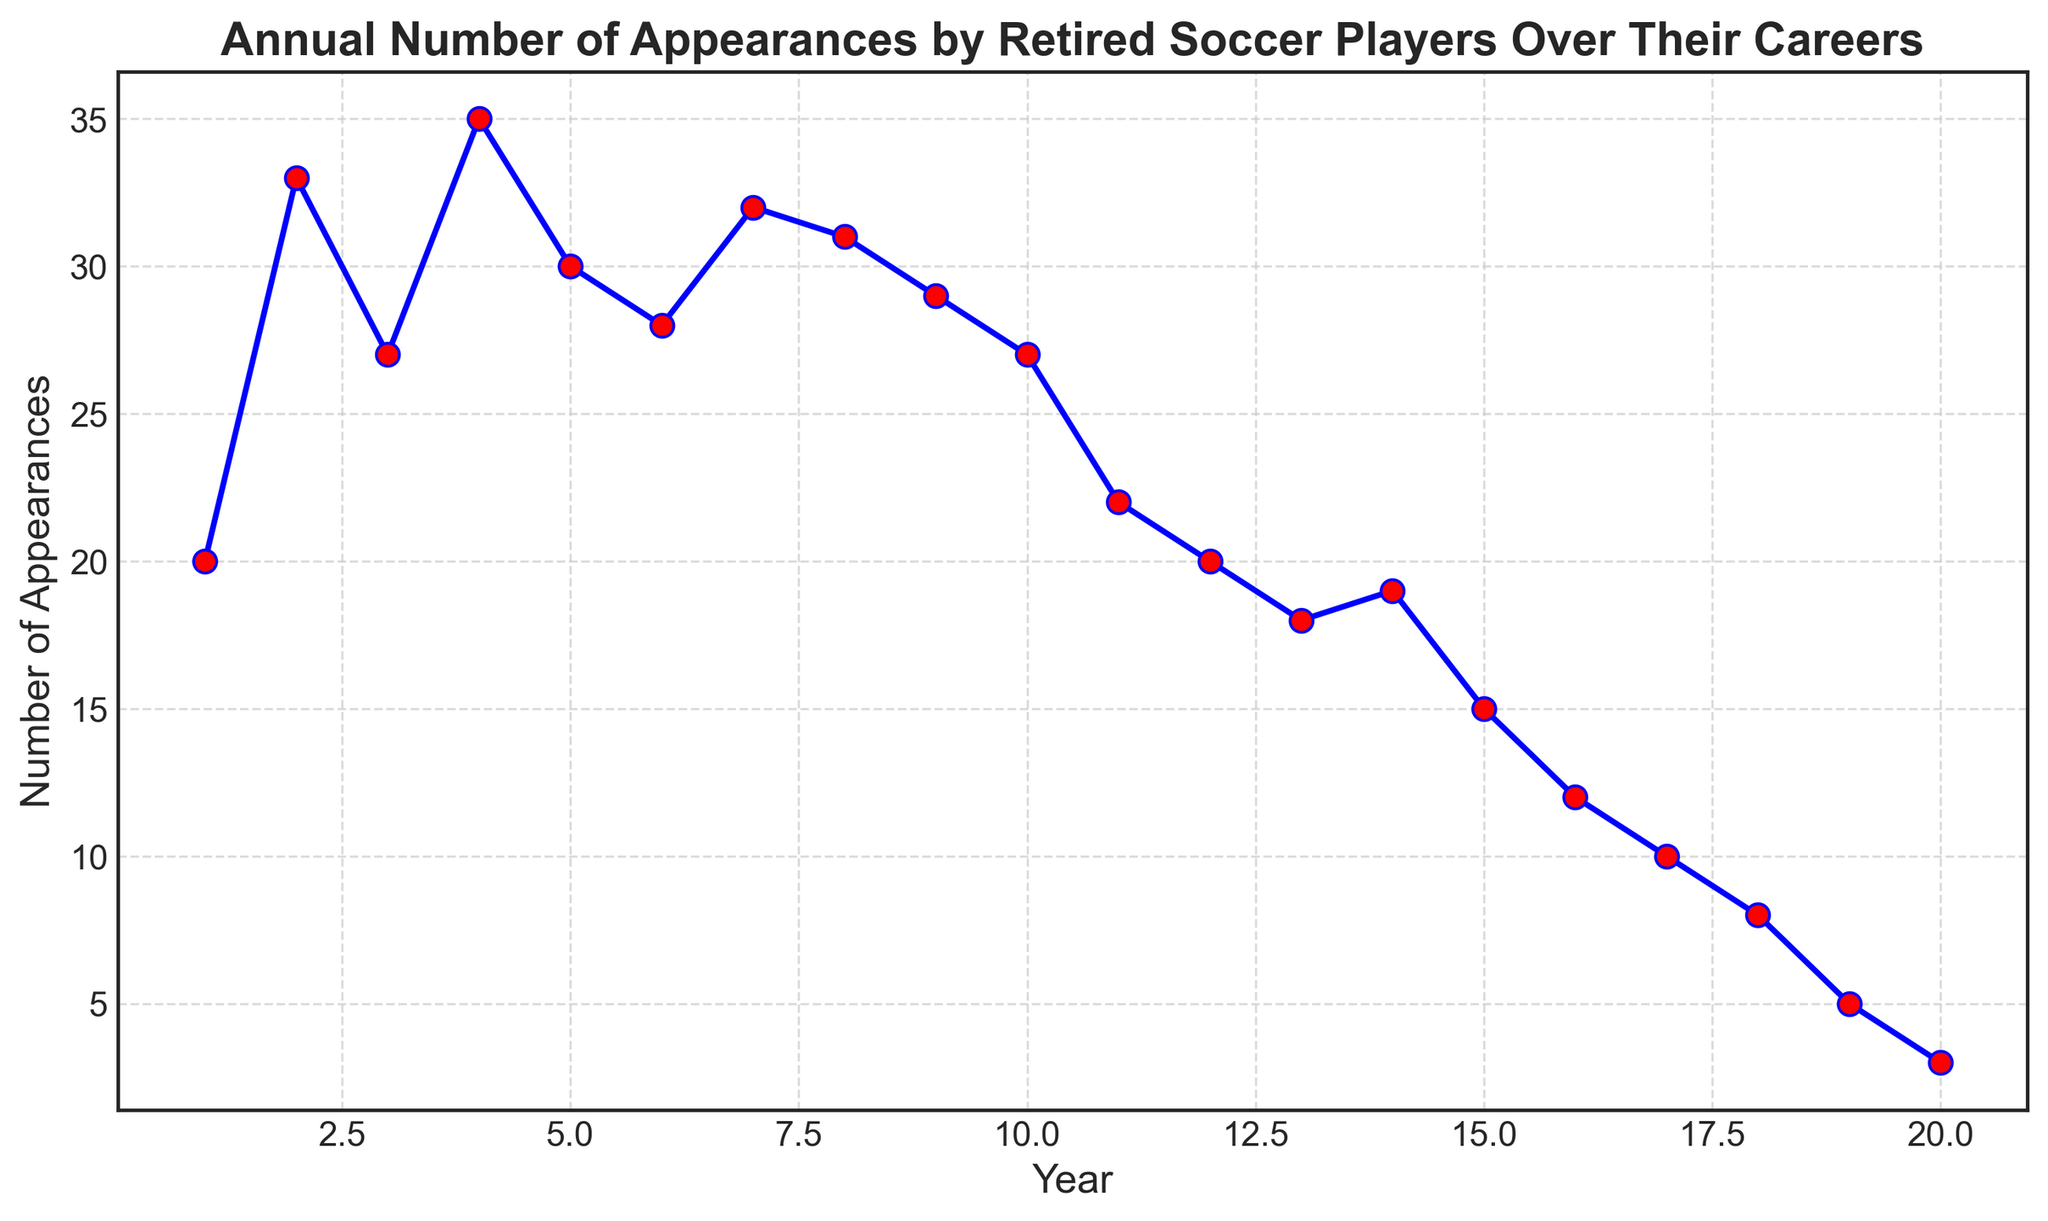What is the highest number of appearances recorded in a single year and which year was it? The highest point on the line chart represents the year with the most appearances. Here, it peaks at year 4 with 35 appearances.
Answer: 35 in Year 4 How many total appearances were made during the first 5 years? Sum the number of appearances from years 1 to 5: 20 + 33 + 27 + 35 + 30 = 145.
Answer: 145 Which year had the lowest number of appearances, and what was the number? The lowest point on the chart indicates the least appearances. This occurs at year 20 with 3 appearances.
Answer: 3 in Year 20 By how much did the number of appearances decline from year 10 to year 20? The appearances in year 10 are 27 and in year 20 are 3. The decline is 27 - 3 = 24.
Answer: 24 Identify two consecutive years between which the number of appearances experienced the largest increase. Look for the steepest upward slope between two consecutive years. Between year 1 (20) and year 2 (33), the increase is 33 - 20 = 13, which is the largest.
Answer: Between Year 1 and Year 2 What is the average number of appearances between years 1 and 10? Sum the appearances from years 1 to 10: (20 + 33 + 27 + 35 + 30 + 28 + 32 + 31 + 29 + 27) = 292. There are 10 years, so average: 292 / 10 = 29.2.
Answer: 29.2 What is the average number of appearances between years 11 and 20? Sum the appearances from years 11 to 20: (22 + 20 + 18 + 19 + 15 + 12 + 10 + 8 + 5 + 3) = 132. There are 10 years, so average: 132 / 10 = 13.2.
Answer: 13.2 How many years did the appearances stay below 20? Count the years where the appearances are less than 20: Years 13 (18), 14 (19), 15 (15), 16 (12), 17 (10), 18 (8), 19 (5), 20 (3), which makes 8 years.
Answer: 8 In which year was the number of appearances closest to the average number of appearances in the first 10 years? The average from the first 10 years is 29.2. Year 9 (29) is the closest to this average.
Answer: Year 9 Compare the differences between the highest number of appearances and the lowest in the first 10 years and the last 10 years. Which span showed a larger difference? First 10 years: Highest = 35 (Year 4), Lowest = 20 (Year 1), Difference = 15 
Last 10 years: Highest = 22 (Year 11), Lowest = 3 (Year 20), Difference = 19 
The last 10 years span showed a larger difference.
Answer: Last 10 years 